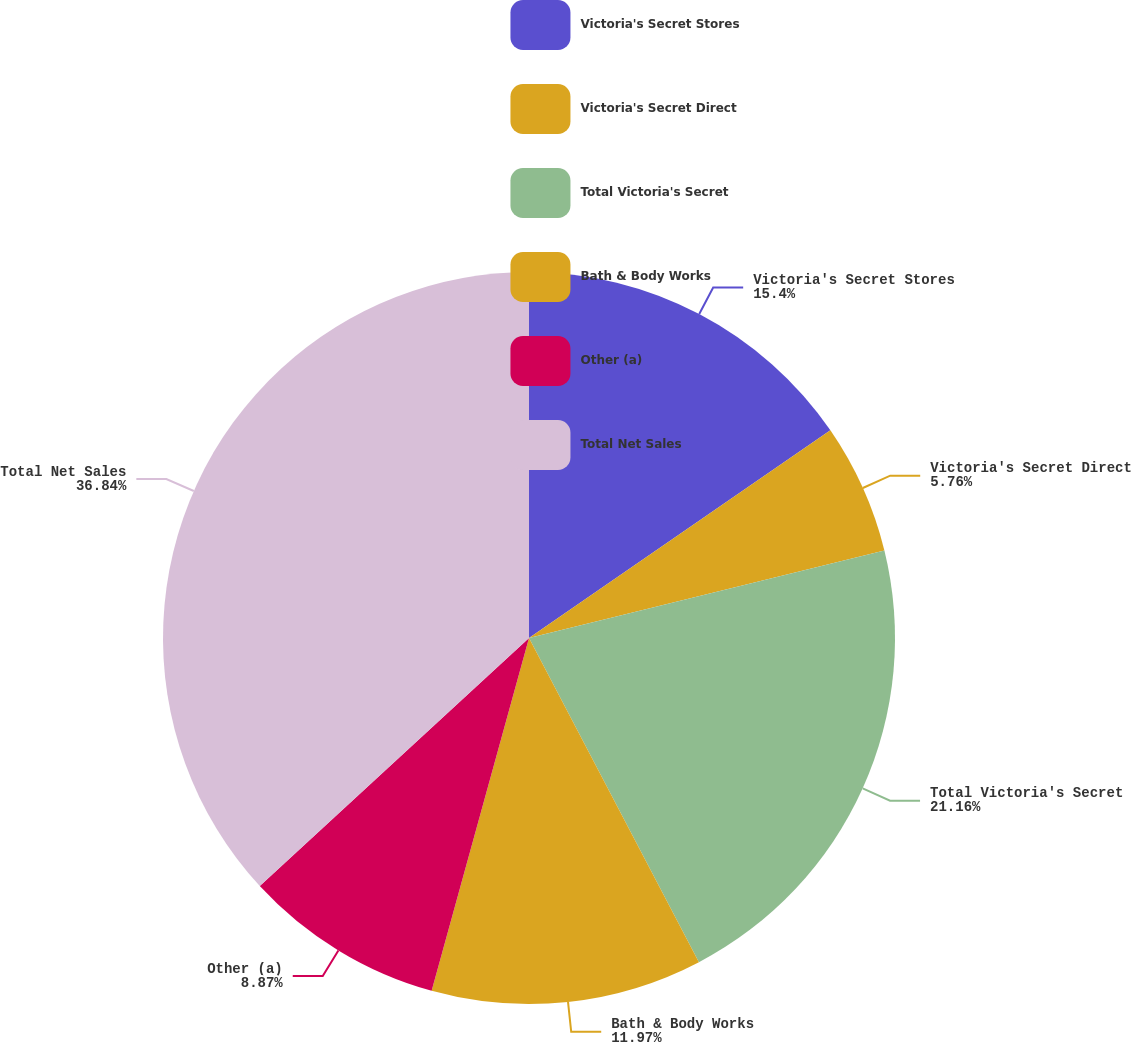Convert chart to OTSL. <chart><loc_0><loc_0><loc_500><loc_500><pie_chart><fcel>Victoria's Secret Stores<fcel>Victoria's Secret Direct<fcel>Total Victoria's Secret<fcel>Bath & Body Works<fcel>Other (a)<fcel>Total Net Sales<nl><fcel>15.4%<fcel>5.76%<fcel>21.16%<fcel>11.97%<fcel>8.87%<fcel>36.85%<nl></chart> 